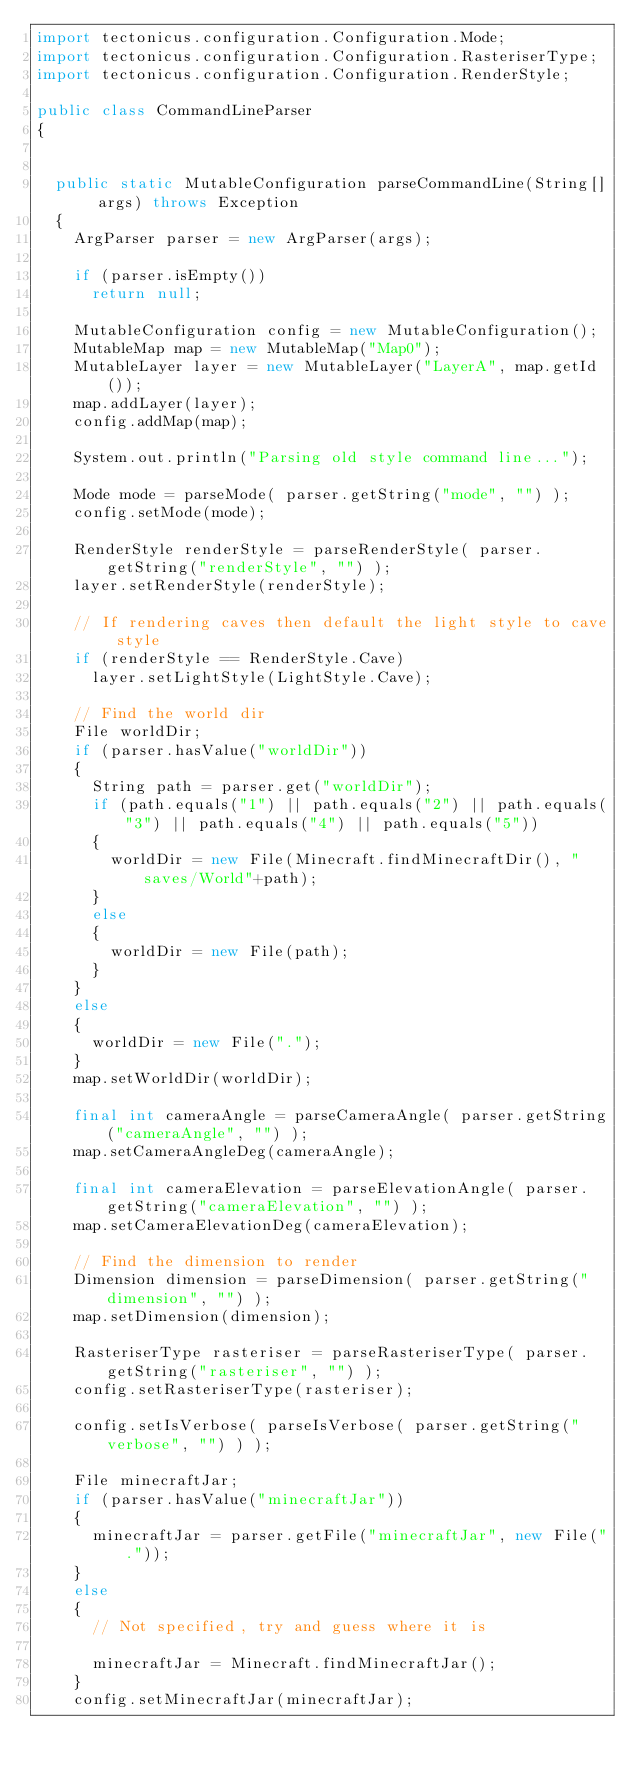Convert code to text. <code><loc_0><loc_0><loc_500><loc_500><_Java_>import tectonicus.configuration.Configuration.Mode;
import tectonicus.configuration.Configuration.RasteriserType;
import tectonicus.configuration.Configuration.RenderStyle;

public class CommandLineParser
{

	
	public static MutableConfiguration parseCommandLine(String[] args) throws Exception
	{
		ArgParser parser = new ArgParser(args);
		
		if (parser.isEmpty())
			return null;
		
		MutableConfiguration config = new MutableConfiguration();
		MutableMap map = new MutableMap("Map0");
		MutableLayer layer = new MutableLayer("LayerA", map.getId());
		map.addLayer(layer);
		config.addMap(map);
		
		System.out.println("Parsing old style command line...");
		
		Mode mode = parseMode( parser.getString("mode", "") );
		config.setMode(mode);
		
		RenderStyle renderStyle = parseRenderStyle( parser.getString("renderStyle", "") );
		layer.setRenderStyle(renderStyle);
		
		// If rendering caves then default the light style to cave style
		if (renderStyle == RenderStyle.Cave)
			layer.setLightStyle(LightStyle.Cave);
		
		// Find the world dir
		File worldDir;
		if (parser.hasValue("worldDir"))
		{
			String path = parser.get("worldDir");
			if (path.equals("1") || path.equals("2") || path.equals("3") || path.equals("4") || path.equals("5"))
			{
				worldDir = new File(Minecraft.findMinecraftDir(), "saves/World"+path);
			}
			else
			{
				worldDir = new File(path);
			}
		}
		else
		{
			worldDir = new File(".");
		}
		map.setWorldDir(worldDir);
		
		final int cameraAngle = parseCameraAngle( parser.getString("cameraAngle", "") );
		map.setCameraAngleDeg(cameraAngle);
		
		final int cameraElevation = parseElevationAngle( parser.getString("cameraElevation", "") );
		map.setCameraElevationDeg(cameraElevation);
		
		// Find the dimension to render
		Dimension dimension = parseDimension( parser.getString("dimension", "") );
		map.setDimension(dimension);
		
		RasteriserType rasteriser = parseRasteriserType( parser.getString("rasteriser", "") );
		config.setRasteriserType(rasteriser);
		
		config.setIsVerbose( parseIsVerbose( parser.getString("verbose", "") ) );
		
		File minecraftJar;
		if (parser.hasValue("minecraftJar"))
		{
			minecraftJar = parser.getFile("minecraftJar", new File("."));
		}
		else
		{
			// Not specified, try and guess where it is
			
			minecraftJar = Minecraft.findMinecraftJar();
		}
		config.setMinecraftJar(minecraftJar);
		</code> 